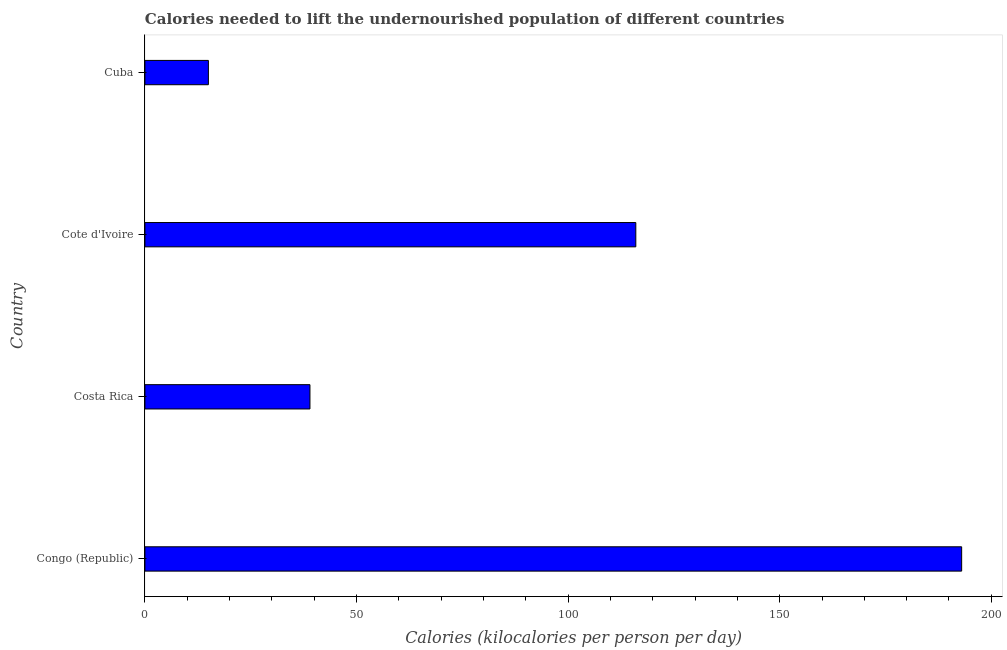What is the title of the graph?
Give a very brief answer. Calories needed to lift the undernourished population of different countries. What is the label or title of the X-axis?
Your answer should be very brief. Calories (kilocalories per person per day). What is the depth of food deficit in Congo (Republic)?
Your answer should be compact. 193. Across all countries, what is the maximum depth of food deficit?
Offer a very short reply. 193. Across all countries, what is the minimum depth of food deficit?
Keep it short and to the point. 15. In which country was the depth of food deficit maximum?
Give a very brief answer. Congo (Republic). In which country was the depth of food deficit minimum?
Provide a succinct answer. Cuba. What is the sum of the depth of food deficit?
Your answer should be compact. 363. What is the difference between the depth of food deficit in Costa Rica and Cote d'Ivoire?
Your response must be concise. -77. What is the average depth of food deficit per country?
Make the answer very short. 90.75. What is the median depth of food deficit?
Your answer should be compact. 77.5. What is the ratio of the depth of food deficit in Congo (Republic) to that in Cuba?
Make the answer very short. 12.87. Is the depth of food deficit in Congo (Republic) less than that in Cote d'Ivoire?
Provide a succinct answer. No. Is the difference between the depth of food deficit in Congo (Republic) and Cuba greater than the difference between any two countries?
Give a very brief answer. Yes. What is the difference between the highest and the lowest depth of food deficit?
Provide a short and direct response. 178. In how many countries, is the depth of food deficit greater than the average depth of food deficit taken over all countries?
Make the answer very short. 2. Are all the bars in the graph horizontal?
Provide a succinct answer. Yes. What is the difference between two consecutive major ticks on the X-axis?
Your answer should be very brief. 50. What is the Calories (kilocalories per person per day) in Congo (Republic)?
Ensure brevity in your answer.  193. What is the Calories (kilocalories per person per day) in Costa Rica?
Offer a very short reply. 39. What is the Calories (kilocalories per person per day) of Cote d'Ivoire?
Ensure brevity in your answer.  116. What is the Calories (kilocalories per person per day) in Cuba?
Keep it short and to the point. 15. What is the difference between the Calories (kilocalories per person per day) in Congo (Republic) and Costa Rica?
Your answer should be very brief. 154. What is the difference between the Calories (kilocalories per person per day) in Congo (Republic) and Cote d'Ivoire?
Make the answer very short. 77. What is the difference between the Calories (kilocalories per person per day) in Congo (Republic) and Cuba?
Your answer should be very brief. 178. What is the difference between the Calories (kilocalories per person per day) in Costa Rica and Cote d'Ivoire?
Offer a terse response. -77. What is the difference between the Calories (kilocalories per person per day) in Costa Rica and Cuba?
Give a very brief answer. 24. What is the difference between the Calories (kilocalories per person per day) in Cote d'Ivoire and Cuba?
Provide a succinct answer. 101. What is the ratio of the Calories (kilocalories per person per day) in Congo (Republic) to that in Costa Rica?
Offer a terse response. 4.95. What is the ratio of the Calories (kilocalories per person per day) in Congo (Republic) to that in Cote d'Ivoire?
Your answer should be very brief. 1.66. What is the ratio of the Calories (kilocalories per person per day) in Congo (Republic) to that in Cuba?
Provide a short and direct response. 12.87. What is the ratio of the Calories (kilocalories per person per day) in Costa Rica to that in Cote d'Ivoire?
Your response must be concise. 0.34. What is the ratio of the Calories (kilocalories per person per day) in Costa Rica to that in Cuba?
Provide a short and direct response. 2.6. What is the ratio of the Calories (kilocalories per person per day) in Cote d'Ivoire to that in Cuba?
Offer a terse response. 7.73. 